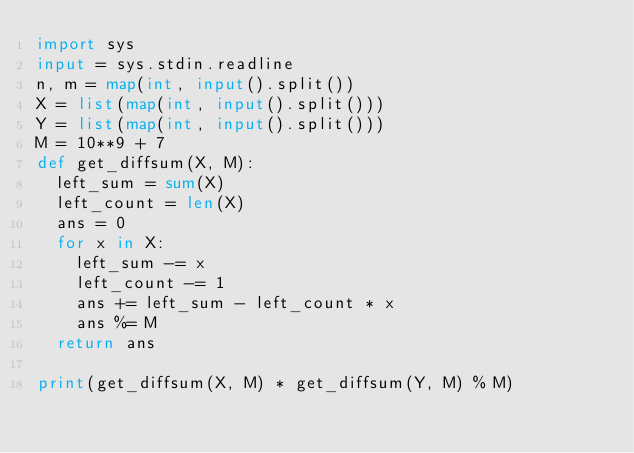<code> <loc_0><loc_0><loc_500><loc_500><_Python_>import sys
input = sys.stdin.readline
n, m = map(int, input().split())
X = list(map(int, input().split()))
Y = list(map(int, input().split()))
M = 10**9 + 7
def get_diffsum(X, M):
  left_sum = sum(X)
  left_count = len(X)
  ans = 0
  for x in X:
    left_sum -= x
    left_count -= 1
    ans += left_sum - left_count * x
    ans %= M
  return ans

print(get_diffsum(X, M) * get_diffsum(Y, M) % M)
</code> 